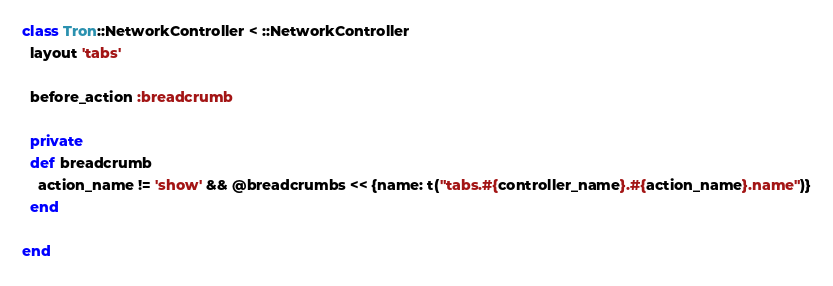<code> <loc_0><loc_0><loc_500><loc_500><_Ruby_>class Tron::NetworkController < ::NetworkController
  layout 'tabs'

  before_action :breadcrumb

  private
  def breadcrumb
    action_name != 'show' && @breadcrumbs << {name: t("tabs.#{controller_name}.#{action_name}.name")}
  end

end
</code> 